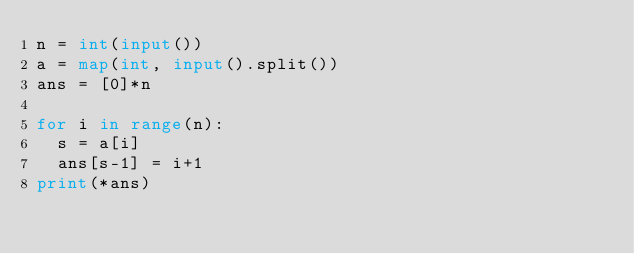Convert code to text. <code><loc_0><loc_0><loc_500><loc_500><_Python_>n = int(input())
a = map(int, input().split())
ans = [0]*n

for i in range(n):
  s = a[i]
  ans[s-1] = i+1
print(*ans)</code> 